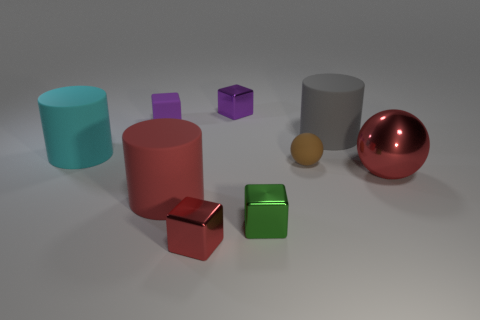What shape is the other large object that is the same color as the large metallic object?
Give a very brief answer. Cylinder. Are there more tiny rubber balls left of the cyan thing than cyan objects?
Keep it short and to the point. No. There is a red cube that is the same material as the large ball; what size is it?
Keep it short and to the point. Small. Are there any rubber cylinders of the same color as the big shiny ball?
Your answer should be very brief. Yes. How many things are small green metal blocks or things that are on the right side of the purple rubber block?
Your answer should be compact. 7. Are there more tiny cubes than big cylinders?
Your response must be concise. Yes. What is the size of the metal object that is the same color as the matte cube?
Keep it short and to the point. Small. Are there any purple cubes that have the same material as the brown thing?
Provide a succinct answer. Yes. The big object that is both to the left of the red cube and right of the cyan rubber cylinder has what shape?
Offer a terse response. Cylinder. What number of other things are there of the same shape as the small purple rubber thing?
Your answer should be very brief. 3. 